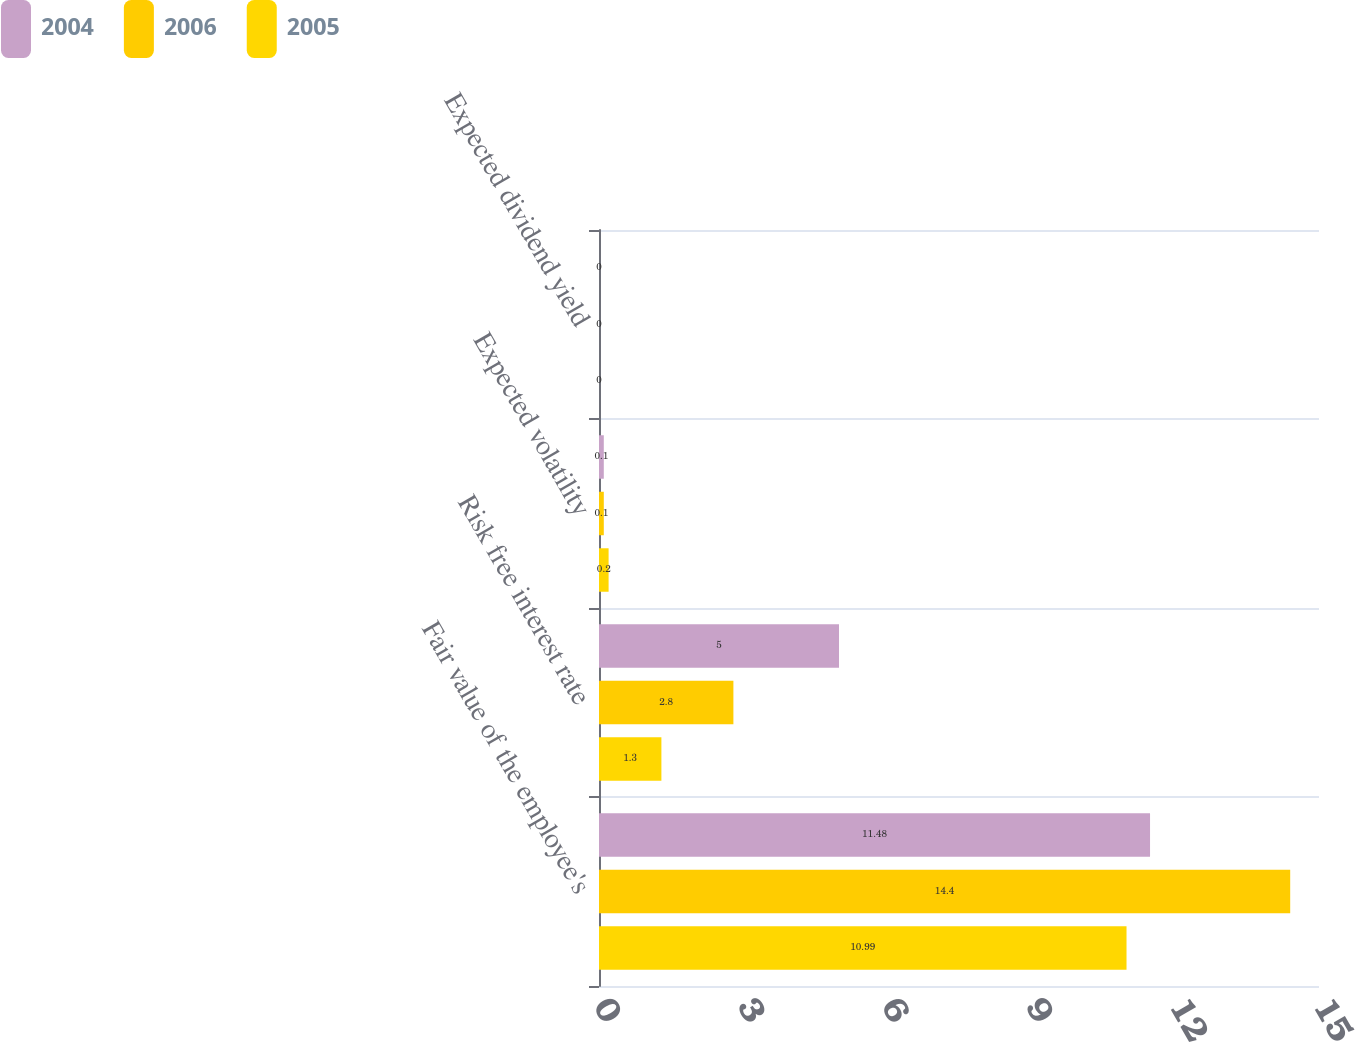Convert chart to OTSL. <chart><loc_0><loc_0><loc_500><loc_500><stacked_bar_chart><ecel><fcel>Fair value of the employee's<fcel>Risk free interest rate<fcel>Expected volatility<fcel>Expected dividend yield<nl><fcel>2004<fcel>11.48<fcel>5<fcel>0.1<fcel>0<nl><fcel>2006<fcel>14.4<fcel>2.8<fcel>0.1<fcel>0<nl><fcel>2005<fcel>10.99<fcel>1.3<fcel>0.2<fcel>0<nl></chart> 